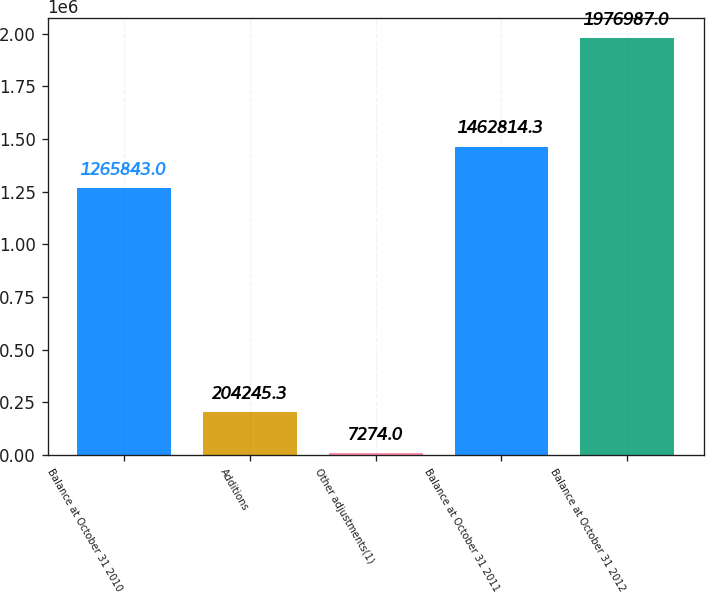<chart> <loc_0><loc_0><loc_500><loc_500><bar_chart><fcel>Balance at October 31 2010<fcel>Additions<fcel>Other adjustments(1)<fcel>Balance at October 31 2011<fcel>Balance at October 31 2012<nl><fcel>1.26584e+06<fcel>204245<fcel>7274<fcel>1.46281e+06<fcel>1.97699e+06<nl></chart> 